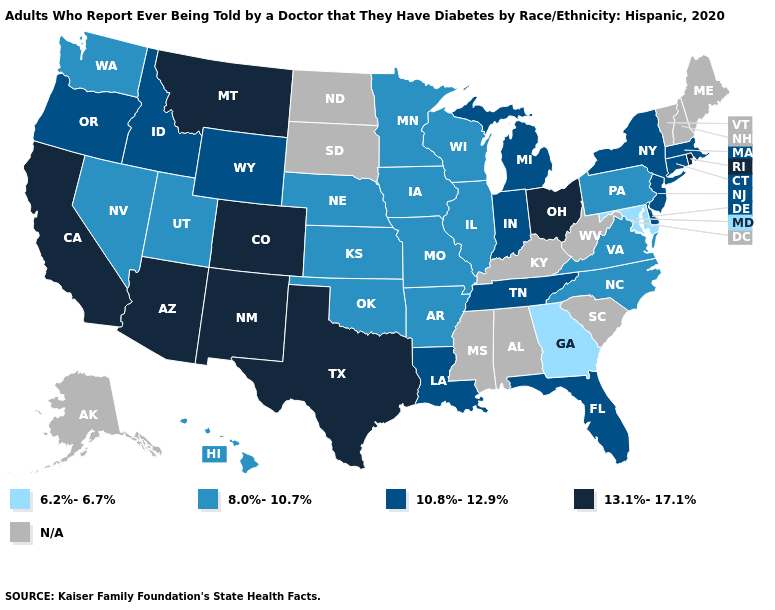What is the lowest value in the MidWest?
Quick response, please. 8.0%-10.7%. What is the value of Arkansas?
Concise answer only. 8.0%-10.7%. What is the highest value in the USA?
Answer briefly. 13.1%-17.1%. What is the value of Iowa?
Be succinct. 8.0%-10.7%. What is the value of Colorado?
Answer briefly. 13.1%-17.1%. Which states hav the highest value in the Northeast?
Answer briefly. Rhode Island. What is the value of West Virginia?
Be succinct. N/A. Name the states that have a value in the range 13.1%-17.1%?
Give a very brief answer. Arizona, California, Colorado, Montana, New Mexico, Ohio, Rhode Island, Texas. What is the highest value in the Northeast ?
Quick response, please. 13.1%-17.1%. Which states hav the highest value in the South?
Keep it brief. Texas. Which states have the lowest value in the MidWest?
Quick response, please. Illinois, Iowa, Kansas, Minnesota, Missouri, Nebraska, Wisconsin. What is the value of Louisiana?
Be succinct. 10.8%-12.9%. Does Louisiana have the highest value in the South?
Write a very short answer. No. Name the states that have a value in the range 10.8%-12.9%?
Quick response, please. Connecticut, Delaware, Florida, Idaho, Indiana, Louisiana, Massachusetts, Michigan, New Jersey, New York, Oregon, Tennessee, Wyoming. 